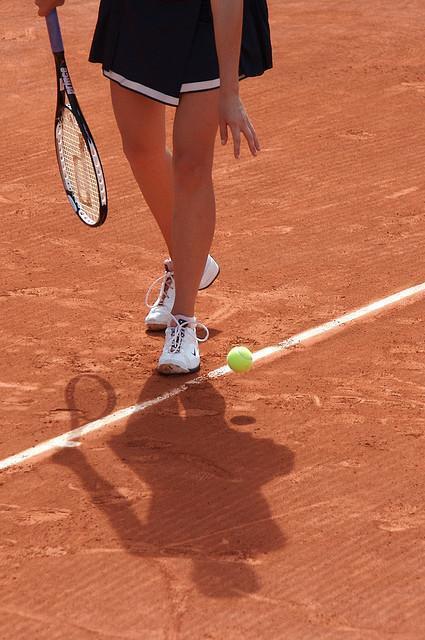What color are the logos on the shoes which this tennis playing woman is wearing?
From the following set of four choices, select the accurate answer to respond to the question.
Options: Pink, red, blue, black. Black. 